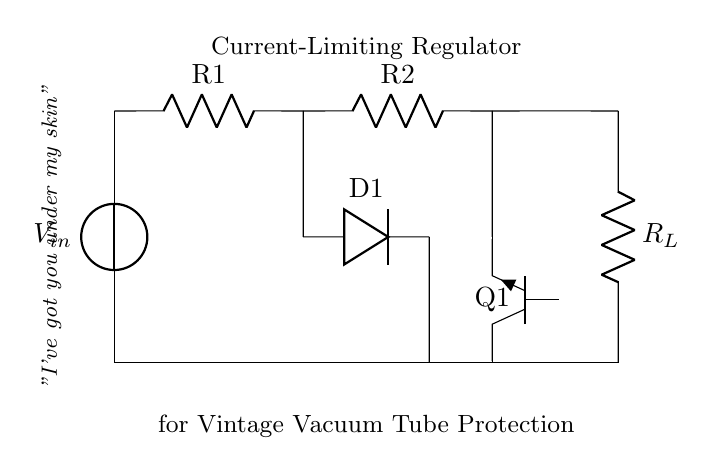What type of transistor is used in this circuit? The circuit shows a bipolar junction transistor labeled as npn (Q1). This is indicated by the symbol and label in the diagram.
Answer: npn What is the function of D1 in this regulator circuit? D1 is a diode used for preventing reverse current flow. In the circuit diagram, its placement indicates that it allows current to flow in one direction while blocking it in the opposite direction.
Answer: preventing reverse current What are the two resistors in this circuit? The circuit contains two resistors, R1 and R2, that are connected in series as indicated by the labels next to them.
Answer: R1, R2 What is the main purpose of this current-limiting regulator? The main purpose is to protect vintage vacuum tube equipment from excessive current by limiting it, as highlighted in the description above the circuit.
Answer: protect vintage equipment How does the current-limiting feature work in this circuit? The current-limiting feature is achieved through the combination of resistors (R1 and R2) and the transistor (Q1) which regulates the output current to a safe level based on its biasing conditions. The arrangement allows the transistor to limit the output when the current reaches a certain threshold.
Answer: through resistors and transistor What happens to the current if the load resistance (R_L) decreases? If the load resistance R_L decreases, the current flowing through the circuit increases. The current-limiting feature will engage, and the transistor will regulate the current to prevent it from exceeding safe levels, thus protecting the circuit.
Answer: current increases, limited by transistor 